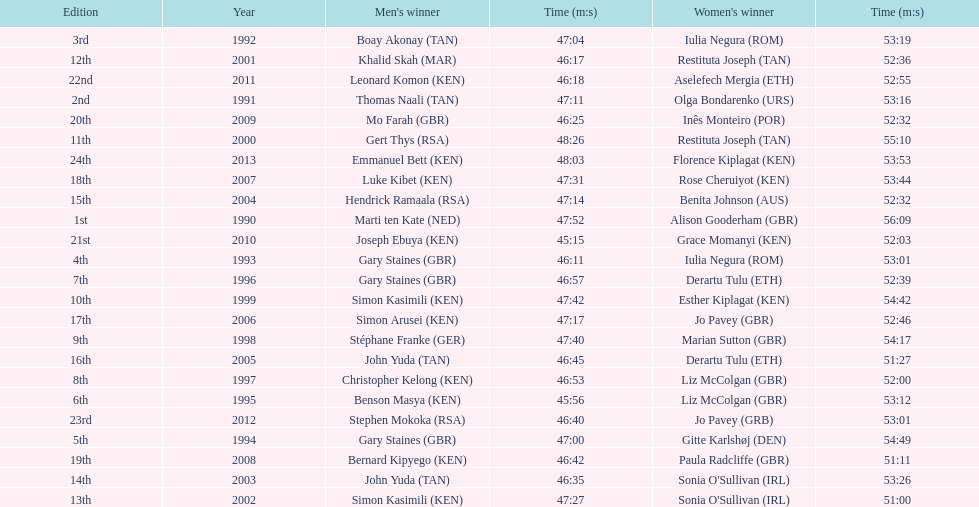Which runners are from kenya? (ken) Benson Masya (KEN), Christopher Kelong (KEN), Simon Kasimili (KEN), Simon Kasimili (KEN), Simon Arusei (KEN), Luke Kibet (KEN), Bernard Kipyego (KEN), Joseph Ebuya (KEN), Leonard Komon (KEN), Emmanuel Bett (KEN). Of these, which times are under 46 minutes? Benson Masya (KEN), Joseph Ebuya (KEN). Which of these runners had the faster time? Joseph Ebuya (KEN). 